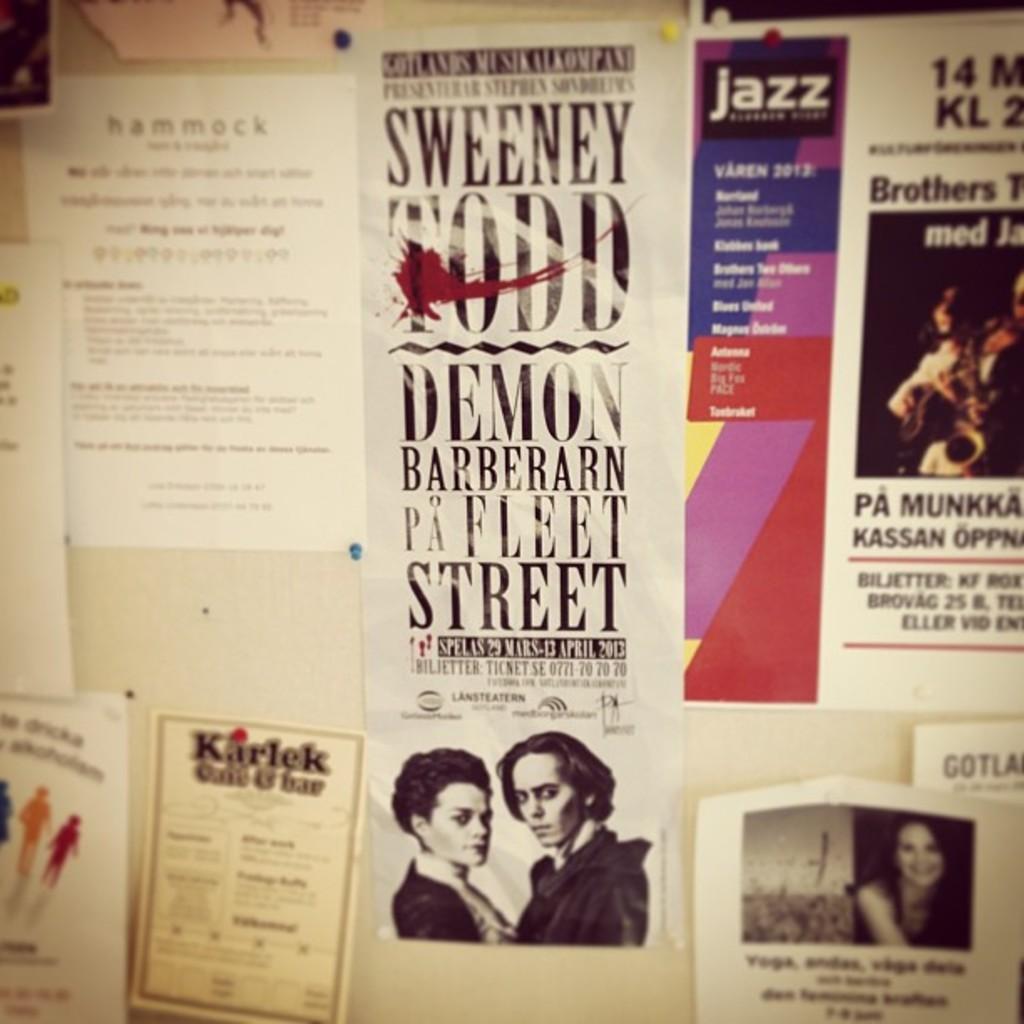Who is sweeny todd?
Give a very brief answer. Unanswerable. What number is on the poster on the right?
Give a very brief answer. 14. 